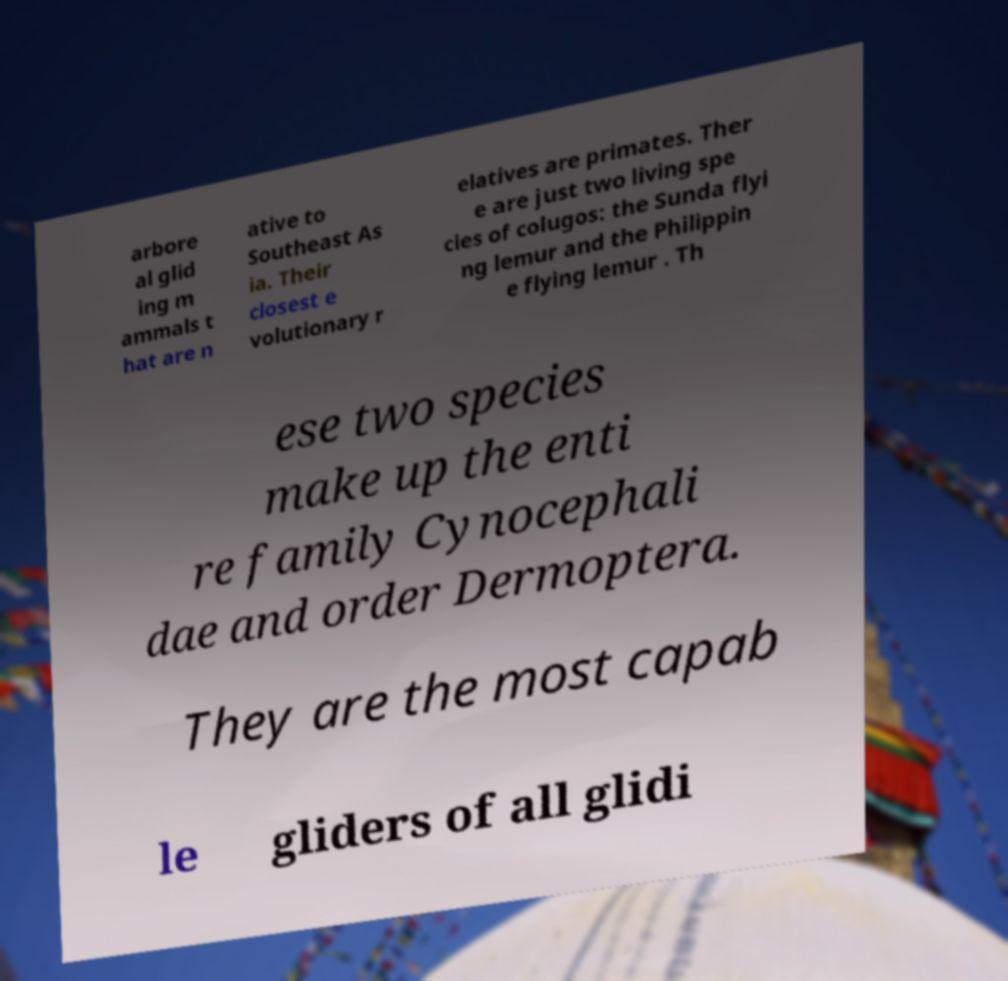Can you accurately transcribe the text from the provided image for me? arbore al glid ing m ammals t hat are n ative to Southeast As ia. Their closest e volutionary r elatives are primates. Ther e are just two living spe cies of colugos: the Sunda flyi ng lemur and the Philippin e flying lemur . Th ese two species make up the enti re family Cynocephali dae and order Dermoptera. They are the most capab le gliders of all glidi 